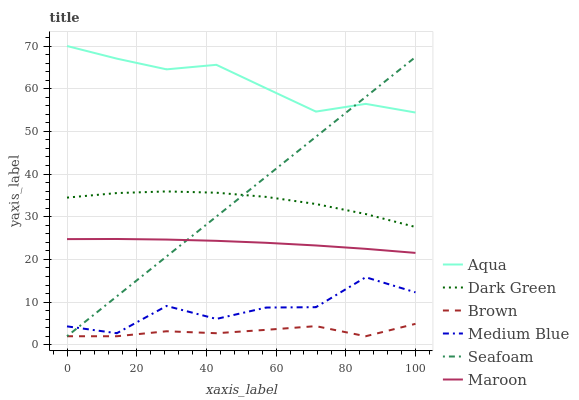Does Brown have the minimum area under the curve?
Answer yes or no. Yes. Does Aqua have the maximum area under the curve?
Answer yes or no. Yes. Does Medium Blue have the minimum area under the curve?
Answer yes or no. No. Does Medium Blue have the maximum area under the curve?
Answer yes or no. No. Is Seafoam the smoothest?
Answer yes or no. Yes. Is Medium Blue the roughest?
Answer yes or no. Yes. Is Aqua the smoothest?
Answer yes or no. No. Is Aqua the roughest?
Answer yes or no. No. Does Brown have the lowest value?
Answer yes or no. Yes. Does Medium Blue have the lowest value?
Answer yes or no. No. Does Aqua have the highest value?
Answer yes or no. Yes. Does Medium Blue have the highest value?
Answer yes or no. No. Is Dark Green less than Aqua?
Answer yes or no. Yes. Is Medium Blue greater than Brown?
Answer yes or no. Yes. Does Seafoam intersect Dark Green?
Answer yes or no. Yes. Is Seafoam less than Dark Green?
Answer yes or no. No. Is Seafoam greater than Dark Green?
Answer yes or no. No. Does Dark Green intersect Aqua?
Answer yes or no. No. 